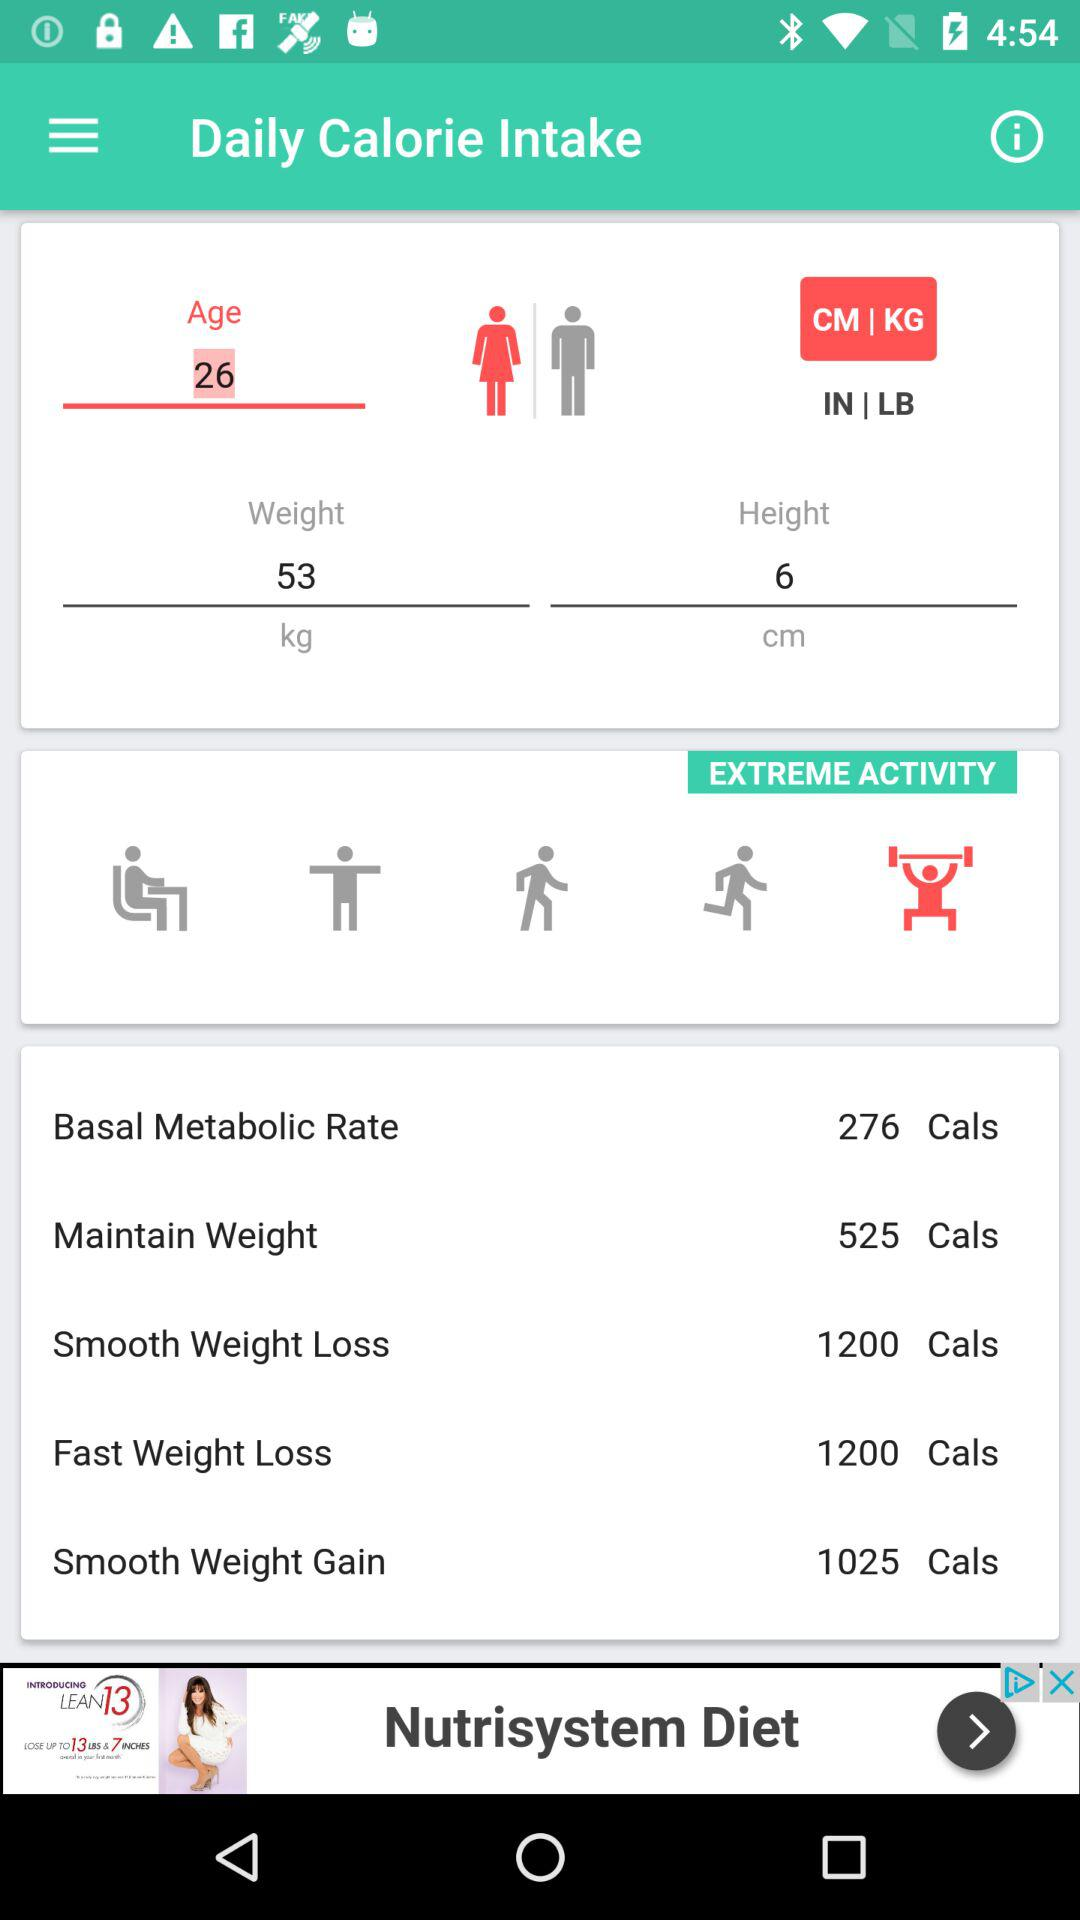What is the name of the application? The name of the application is "Daily Calorie Intake". 